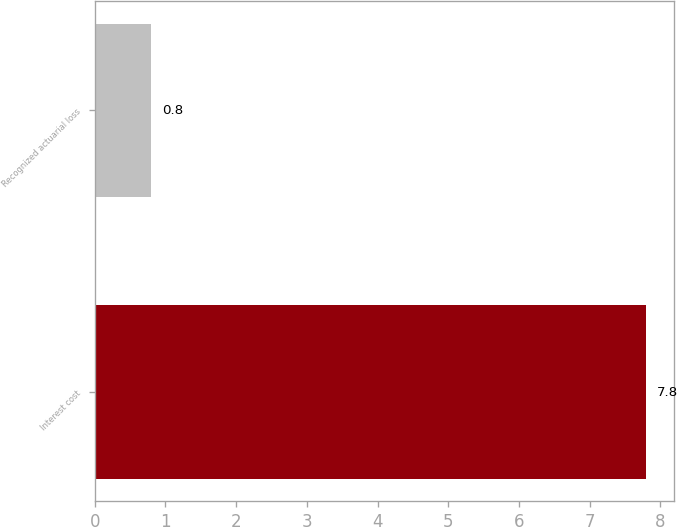Convert chart. <chart><loc_0><loc_0><loc_500><loc_500><bar_chart><fcel>Interest cost<fcel>Recognized actuarial loss<nl><fcel>7.8<fcel>0.8<nl></chart> 